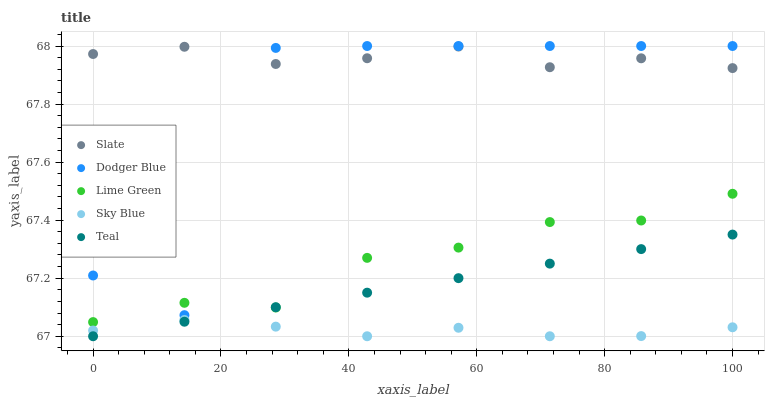Does Sky Blue have the minimum area under the curve?
Answer yes or no. Yes. Does Slate have the maximum area under the curve?
Answer yes or no. Yes. Does Dodger Blue have the minimum area under the curve?
Answer yes or no. No. Does Dodger Blue have the maximum area under the curve?
Answer yes or no. No. Is Teal the smoothest?
Answer yes or no. Yes. Is Dodger Blue the roughest?
Answer yes or no. Yes. Is Slate the smoothest?
Answer yes or no. No. Is Slate the roughest?
Answer yes or no. No. Does Teal have the lowest value?
Answer yes or no. Yes. Does Dodger Blue have the lowest value?
Answer yes or no. No. Does Dodger Blue have the highest value?
Answer yes or no. Yes. Does Slate have the highest value?
Answer yes or no. No. Is Sky Blue less than Lime Green?
Answer yes or no. Yes. Is Slate greater than Lime Green?
Answer yes or no. Yes. Does Lime Green intersect Teal?
Answer yes or no. Yes. Is Lime Green less than Teal?
Answer yes or no. No. Is Lime Green greater than Teal?
Answer yes or no. No. Does Sky Blue intersect Lime Green?
Answer yes or no. No. 